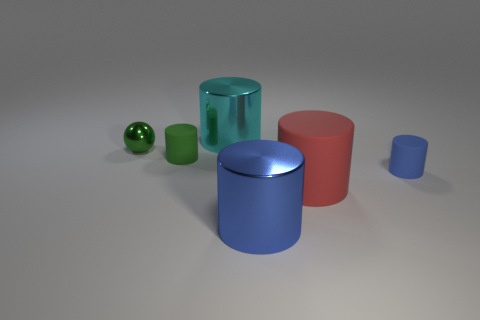Subtract all red cylinders. How many cylinders are left? 4 Subtract all small green cylinders. How many cylinders are left? 4 Subtract all yellow cylinders. Subtract all brown cubes. How many cylinders are left? 5 Add 3 small blue matte things. How many objects exist? 9 Subtract all cylinders. How many objects are left? 1 Subtract 0 purple cylinders. How many objects are left? 6 Subtract all green cylinders. Subtract all red matte things. How many objects are left? 4 Add 1 green matte objects. How many green matte objects are left? 2 Add 6 tiny yellow matte cylinders. How many tiny yellow matte cylinders exist? 6 